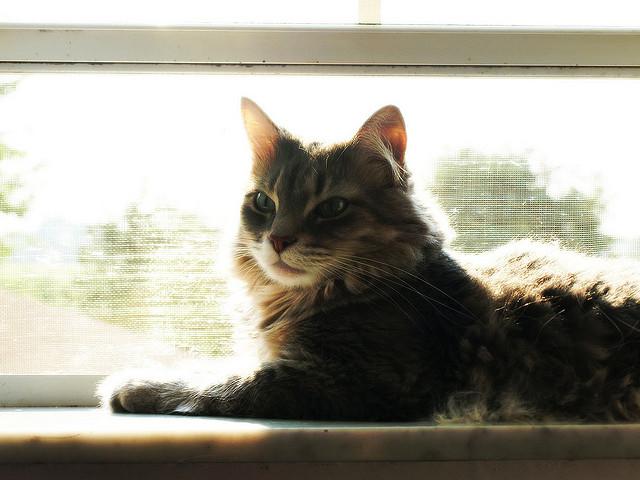What color is the cat's fur?
Give a very brief answer. Brown. Is the cat content?
Keep it brief. Yes. What is behind the cat?
Answer briefly. Window. Where is the cat looking?
Keep it brief. Left. 